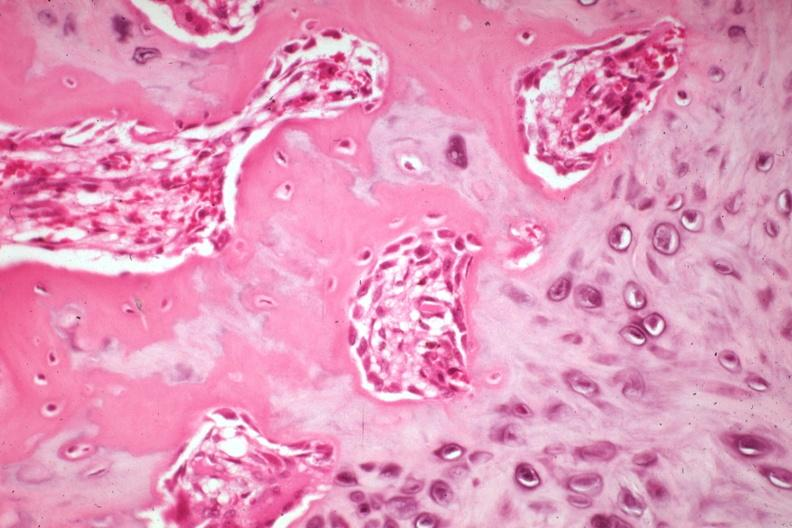what does this image show?
Answer the question using a single word or phrase. High osteoid deposition with new bone formation and osteoblasts also cartilage excellent example case is a non-union 